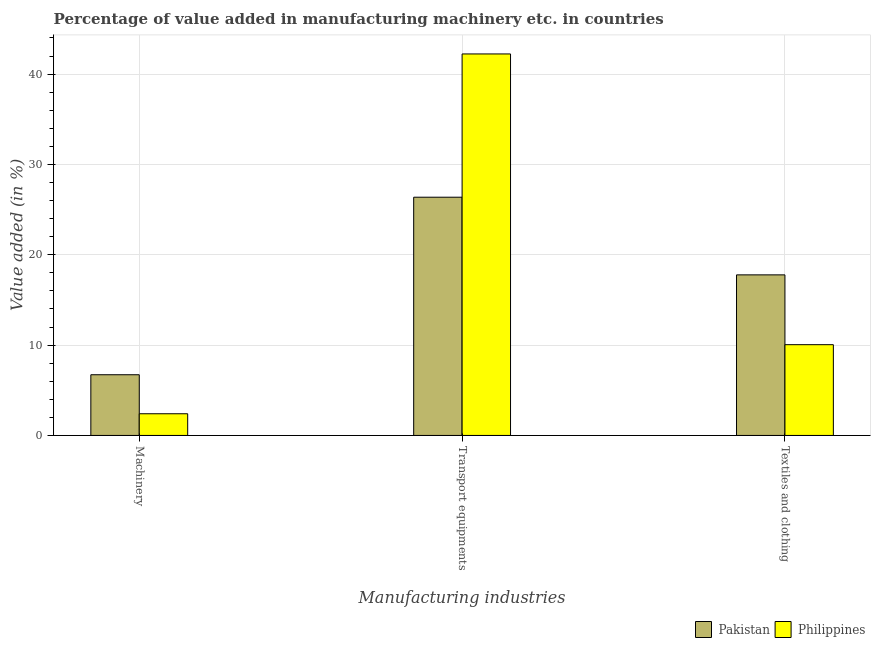How many groups of bars are there?
Your answer should be very brief. 3. Are the number of bars per tick equal to the number of legend labels?
Provide a short and direct response. Yes. How many bars are there on the 2nd tick from the right?
Provide a short and direct response. 2. What is the label of the 1st group of bars from the left?
Make the answer very short. Machinery. What is the value added in manufacturing textile and clothing in Philippines?
Your answer should be very brief. 10.05. Across all countries, what is the maximum value added in manufacturing textile and clothing?
Give a very brief answer. 17.77. Across all countries, what is the minimum value added in manufacturing transport equipments?
Ensure brevity in your answer.  26.37. In which country was the value added in manufacturing textile and clothing minimum?
Ensure brevity in your answer.  Philippines. What is the total value added in manufacturing textile and clothing in the graph?
Ensure brevity in your answer.  27.82. What is the difference between the value added in manufacturing transport equipments in Pakistan and that in Philippines?
Keep it short and to the point. -15.86. What is the difference between the value added in manufacturing textile and clothing in Pakistan and the value added in manufacturing transport equipments in Philippines?
Keep it short and to the point. -24.45. What is the average value added in manufacturing machinery per country?
Your answer should be compact. 4.56. What is the difference between the value added in manufacturing machinery and value added in manufacturing textile and clothing in Philippines?
Give a very brief answer. -7.65. What is the ratio of the value added in manufacturing machinery in Pakistan to that in Philippines?
Your response must be concise. 2.8. Is the value added in manufacturing machinery in Philippines less than that in Pakistan?
Your response must be concise. Yes. Is the difference between the value added in manufacturing transport equipments in Philippines and Pakistan greater than the difference between the value added in manufacturing machinery in Philippines and Pakistan?
Keep it short and to the point. Yes. What is the difference between the highest and the second highest value added in manufacturing transport equipments?
Keep it short and to the point. 15.86. What is the difference between the highest and the lowest value added in manufacturing transport equipments?
Keep it short and to the point. 15.86. What does the 1st bar from the left in Machinery represents?
Ensure brevity in your answer.  Pakistan. How many bars are there?
Ensure brevity in your answer.  6. Are all the bars in the graph horizontal?
Your answer should be very brief. No. How many countries are there in the graph?
Your response must be concise. 2. What is the difference between two consecutive major ticks on the Y-axis?
Offer a very short reply. 10. Are the values on the major ticks of Y-axis written in scientific E-notation?
Your answer should be compact. No. Does the graph contain any zero values?
Provide a succinct answer. No. Does the graph contain grids?
Provide a short and direct response. Yes. Where does the legend appear in the graph?
Provide a short and direct response. Bottom right. What is the title of the graph?
Your answer should be very brief. Percentage of value added in manufacturing machinery etc. in countries. Does "Trinidad and Tobago" appear as one of the legend labels in the graph?
Ensure brevity in your answer.  No. What is the label or title of the X-axis?
Offer a terse response. Manufacturing industries. What is the label or title of the Y-axis?
Offer a very short reply. Value added (in %). What is the Value added (in %) of Pakistan in Machinery?
Give a very brief answer. 6.72. What is the Value added (in %) of Philippines in Machinery?
Make the answer very short. 2.4. What is the Value added (in %) in Pakistan in Transport equipments?
Make the answer very short. 26.37. What is the Value added (in %) of Philippines in Transport equipments?
Make the answer very short. 42.23. What is the Value added (in %) of Pakistan in Textiles and clothing?
Provide a short and direct response. 17.77. What is the Value added (in %) of Philippines in Textiles and clothing?
Your answer should be compact. 10.05. Across all Manufacturing industries, what is the maximum Value added (in %) in Pakistan?
Provide a succinct answer. 26.37. Across all Manufacturing industries, what is the maximum Value added (in %) of Philippines?
Give a very brief answer. 42.23. Across all Manufacturing industries, what is the minimum Value added (in %) in Pakistan?
Provide a succinct answer. 6.72. Across all Manufacturing industries, what is the minimum Value added (in %) of Philippines?
Provide a succinct answer. 2.4. What is the total Value added (in %) in Pakistan in the graph?
Offer a terse response. 50.86. What is the total Value added (in %) of Philippines in the graph?
Provide a short and direct response. 54.68. What is the difference between the Value added (in %) in Pakistan in Machinery and that in Transport equipments?
Make the answer very short. -19.65. What is the difference between the Value added (in %) in Philippines in Machinery and that in Transport equipments?
Your answer should be compact. -39.83. What is the difference between the Value added (in %) of Pakistan in Machinery and that in Textiles and clothing?
Provide a short and direct response. -11.05. What is the difference between the Value added (in %) in Philippines in Machinery and that in Textiles and clothing?
Keep it short and to the point. -7.65. What is the difference between the Value added (in %) of Pakistan in Transport equipments and that in Textiles and clothing?
Provide a succinct answer. 8.6. What is the difference between the Value added (in %) of Philippines in Transport equipments and that in Textiles and clothing?
Offer a very short reply. 32.18. What is the difference between the Value added (in %) of Pakistan in Machinery and the Value added (in %) of Philippines in Transport equipments?
Offer a terse response. -35.51. What is the difference between the Value added (in %) of Pakistan in Machinery and the Value added (in %) of Philippines in Textiles and clothing?
Provide a short and direct response. -3.33. What is the difference between the Value added (in %) in Pakistan in Transport equipments and the Value added (in %) in Philippines in Textiles and clothing?
Keep it short and to the point. 16.32. What is the average Value added (in %) of Pakistan per Manufacturing industries?
Your answer should be compact. 16.95. What is the average Value added (in %) of Philippines per Manufacturing industries?
Your response must be concise. 18.23. What is the difference between the Value added (in %) in Pakistan and Value added (in %) in Philippines in Machinery?
Offer a terse response. 4.32. What is the difference between the Value added (in %) in Pakistan and Value added (in %) in Philippines in Transport equipments?
Your response must be concise. -15.86. What is the difference between the Value added (in %) in Pakistan and Value added (in %) in Philippines in Textiles and clothing?
Provide a short and direct response. 7.73. What is the ratio of the Value added (in %) of Pakistan in Machinery to that in Transport equipments?
Offer a terse response. 0.25. What is the ratio of the Value added (in %) in Philippines in Machinery to that in Transport equipments?
Provide a short and direct response. 0.06. What is the ratio of the Value added (in %) in Pakistan in Machinery to that in Textiles and clothing?
Offer a very short reply. 0.38. What is the ratio of the Value added (in %) in Philippines in Machinery to that in Textiles and clothing?
Offer a terse response. 0.24. What is the ratio of the Value added (in %) in Pakistan in Transport equipments to that in Textiles and clothing?
Ensure brevity in your answer.  1.48. What is the ratio of the Value added (in %) of Philippines in Transport equipments to that in Textiles and clothing?
Provide a short and direct response. 4.2. What is the difference between the highest and the second highest Value added (in %) of Pakistan?
Provide a short and direct response. 8.6. What is the difference between the highest and the second highest Value added (in %) in Philippines?
Offer a terse response. 32.18. What is the difference between the highest and the lowest Value added (in %) of Pakistan?
Give a very brief answer. 19.65. What is the difference between the highest and the lowest Value added (in %) of Philippines?
Provide a succinct answer. 39.83. 